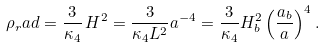Convert formula to latex. <formula><loc_0><loc_0><loc_500><loc_500>\rho _ { r } a d = \frac { 3 } { \kappa _ { 4 } } \, H ^ { 2 } = \frac { 3 } { \kappa _ { 4 } L ^ { 2 } } a ^ { - 4 } = \frac { 3 } { \kappa _ { 4 } } H _ { b } ^ { 2 } \left ( \frac { a _ { b } } { a } \right ) ^ { 4 } .</formula> 